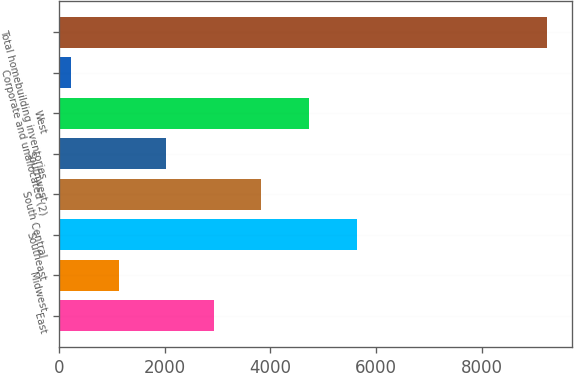Convert chart to OTSL. <chart><loc_0><loc_0><loc_500><loc_500><bar_chart><fcel>East<fcel>Midwest<fcel>Southeast<fcel>South Central<fcel>Southwest<fcel>West<fcel>Corporate and unallocated (2)<fcel>Total homebuilding inventories<nl><fcel>2928.84<fcel>1126.48<fcel>5632.38<fcel>3830.02<fcel>2027.66<fcel>4731.2<fcel>225.3<fcel>9237.1<nl></chart> 